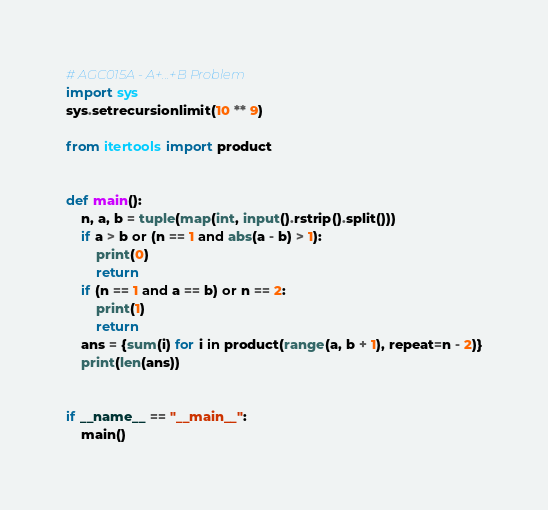<code> <loc_0><loc_0><loc_500><loc_500><_Python_># AGC015A - A+...+B Problem
import sys
sys.setrecursionlimit(10 ** 9)

from itertools import product


def main():
    n, a, b = tuple(map(int, input().rstrip().split()))
    if a > b or (n == 1 and abs(a - b) > 1):
        print(0)
        return
    if (n == 1 and a == b) or n == 2:
        print(1)
        return
    ans = {sum(i) for i in product(range(a, b + 1), repeat=n - 2)}
    print(len(ans))


if __name__ == "__main__":
    main()</code> 